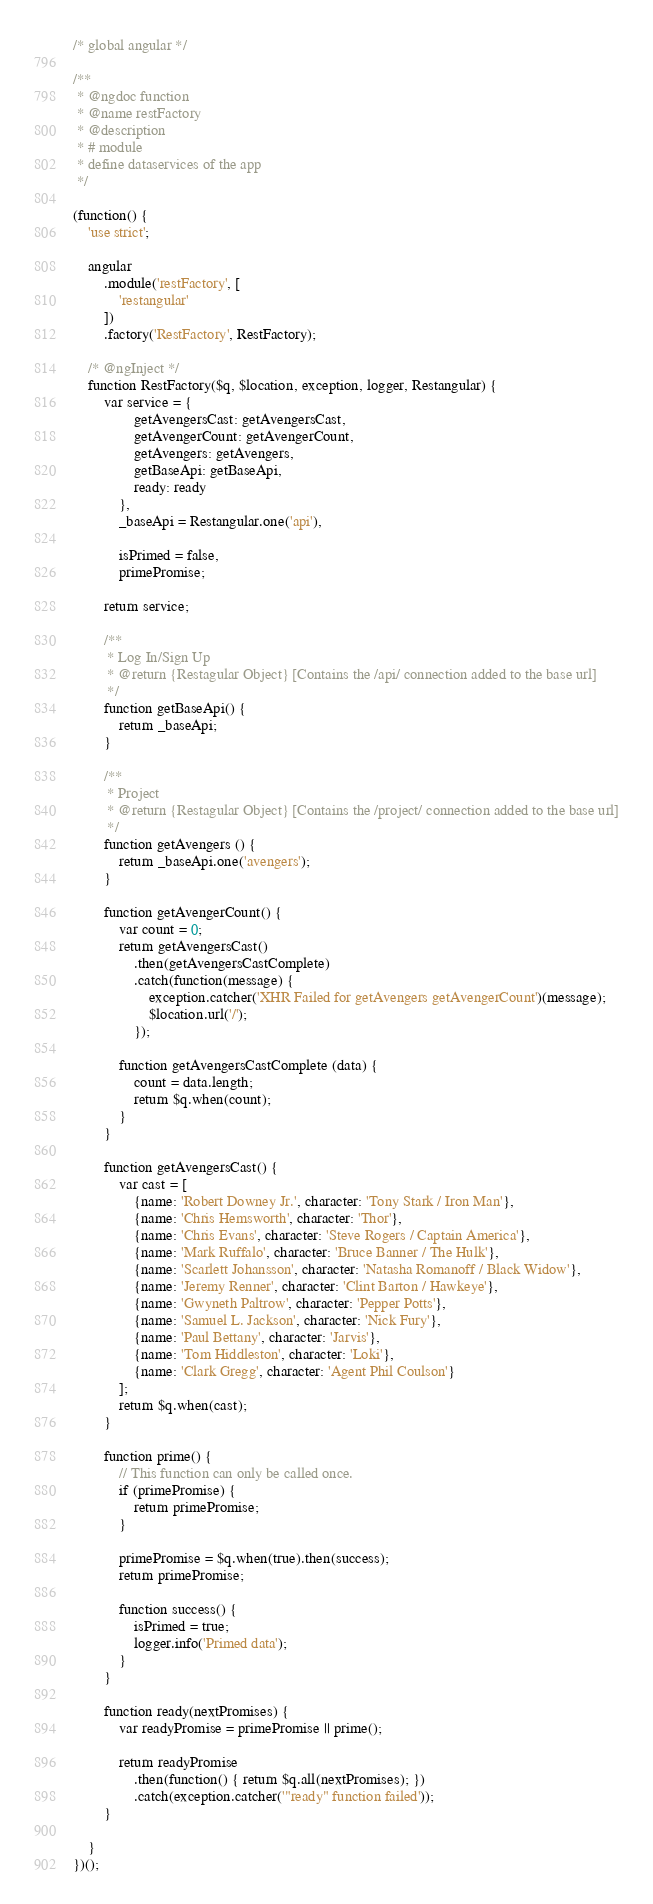Convert code to text. <code><loc_0><loc_0><loc_500><loc_500><_JavaScript_>/* global angular */

/**
 * @ngdoc function
 * @name restFactory
 * @description
 * # module
 * define dataservices of the app
 */

(function() {
    'use strict';

    angular
        .module('restFactory', [
            'restangular'
        ])
        .factory('RestFactory', RestFactory);

    /* @ngInject */
    function RestFactory($q, $location, exception, logger, Restangular) {
        var service = {
                getAvengersCast: getAvengersCast,
                getAvengerCount: getAvengerCount,
                getAvengers: getAvengers,
                getBaseApi: getBaseApi,
                ready: ready
            },
            _baseApi = Restangular.one('api'),

            isPrimed = false,
            primePromise;

        return service;

        /**
         * Log In/Sign Up
         * @return {Restagular Object} [Contains the /api/ connection added to the base url]
         */
        function getBaseApi() {
            return _baseApi;
        }

        /**
         * Project
         * @return {Restagular Object} [Contains the /project/ connection added to the base url]
         */
        function getAvengers () {
            return _baseApi.one('avengers');
        }

        function getAvengerCount() {
            var count = 0;
            return getAvengersCast()
                .then(getAvengersCastComplete)
                .catch(function(message) {
                    exception.catcher('XHR Failed for getAvengers getAvengerCount')(message);
                    $location.url('/');
                });

            function getAvengersCastComplete (data) {
                count = data.length;
                return $q.when(count);
            }
        }

        function getAvengersCast() {
            var cast = [
                {name: 'Robert Downey Jr.', character: 'Tony Stark / Iron Man'},
                {name: 'Chris Hemsworth', character: 'Thor'},
                {name: 'Chris Evans', character: 'Steve Rogers / Captain America'},
                {name: 'Mark Ruffalo', character: 'Bruce Banner / The Hulk'},
                {name: 'Scarlett Johansson', character: 'Natasha Romanoff / Black Widow'},
                {name: 'Jeremy Renner', character: 'Clint Barton / Hawkeye'},
                {name: 'Gwyneth Paltrow', character: 'Pepper Potts'},
                {name: 'Samuel L. Jackson', character: 'Nick Fury'},
                {name: 'Paul Bettany', character: 'Jarvis'},
                {name: 'Tom Hiddleston', character: 'Loki'},
                {name: 'Clark Gregg', character: 'Agent Phil Coulson'}
            ];
            return $q.when(cast);
        }

        function prime() {
            // This function can only be called once.
            if (primePromise) {
                return primePromise;
            }

            primePromise = $q.when(true).then(success);
            return primePromise;

            function success() {
                isPrimed = true;
                logger.info('Primed data');
            }
        }

        function ready(nextPromises) {
            var readyPromise = primePromise || prime();

            return readyPromise
                .then(function() { return $q.all(nextPromises); })
                .catch(exception.catcher('"ready" function failed'));
        }

    }
})();
</code> 